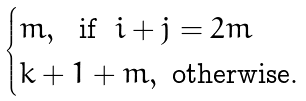<formula> <loc_0><loc_0><loc_500><loc_500>\begin{cases} m , \ \text { if } \ i + j = 2 m \\ k + 1 + m , \ \text {otherwise.} \end{cases}</formula> 